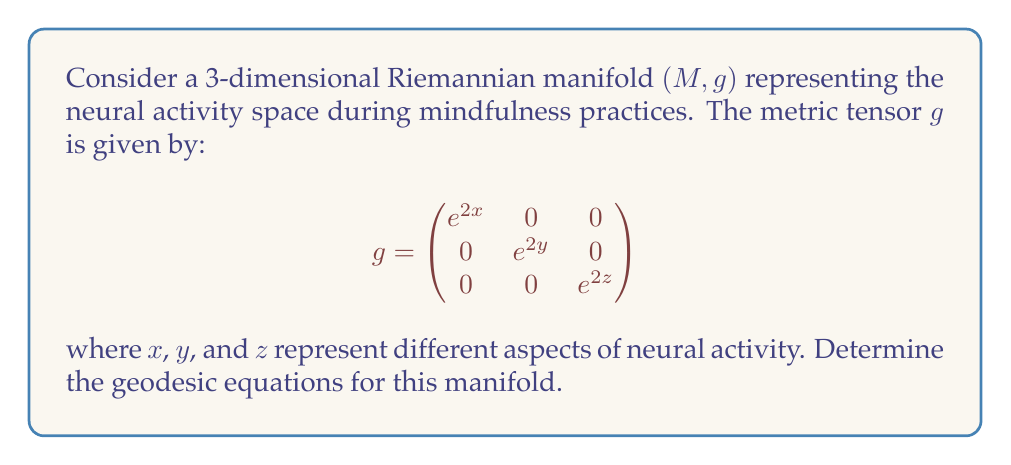Give your solution to this math problem. To find the geodesic equations, we need to follow these steps:

1) First, we calculate the Christoffel symbols $\Gamma^k_{ij}$ using the formula:

   $$\Gamma^k_{ij} = \frac{1}{2}g^{kl}\left(\frac{\partial g_{il}}{\partial x^j} + \frac{\partial g_{jl}}{\partial x^i} - \frac{\partial g_{ij}}{\partial x^l}\right)$$

2) The inverse metric $g^{ij}$ is:

   $$g^{ij} = \begin{pmatrix}
   e^{-2x} & 0 & 0 \\
   0 & e^{-2y} & 0 \\
   0 & 0 & e^{-2z}
   \end{pmatrix}$$

3) Calculating the non-zero Christoffel symbols:

   $\Gamma^1_{11} = \frac{1}{2}g^{11}\frac{\partial g_{11}}{\partial x} = e^{-2x} \cdot 2e^{2x} = 1$
   
   $\Gamma^2_{22} = \frac{1}{2}g^{22}\frac{\partial g_{22}}{\partial y} = e^{-2y} \cdot 2e^{2y} = 1$
   
   $\Gamma^3_{33} = \frac{1}{2}g^{33}\frac{\partial g_{33}}{\partial z} = e^{-2z} \cdot 2e^{2z} = 1$

4) The geodesic equations are given by:

   $$\frac{d^2x^k}{dt^2} + \Gamma^k_{ij}\frac{dx^i}{dt}\frac{dx^j}{dt} = 0$$

5) Substituting the Christoffel symbols, we get:

   $$\frac{d^2x}{dt^2} + \left(\frac{dx}{dt}\right)^2 = 0$$
   
   $$\frac{d^2y}{dt^2} + \left(\frac{dy}{dt}\right)^2 = 0$$
   
   $$\frac{d^2z}{dt^2} + \left(\frac{dz}{dt}\right)^2 = 0$$

These are the geodesic equations for the given Riemannian manifold.
Answer: $$\frac{d^2x}{dt^2} + \left(\frac{dx}{dt}\right)^2 = 0,\quad \frac{d^2y}{dt^2} + \left(\frac{dy}{dt}\right)^2 = 0,\quad \frac{d^2z}{dt^2} + \left(\frac{dz}{dt}\right)^2 = 0$$ 